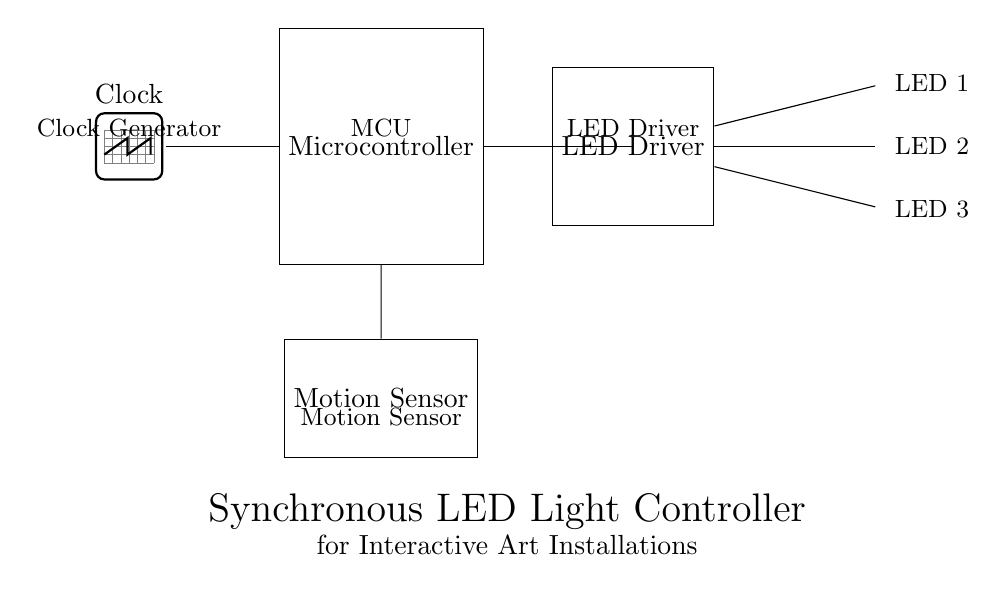what type of sensor is used in this circuit? The circuit diagram indicates a motion sensor, which is depicted in a rectangular shape labeled as "Motion Sensor". This is visible in the lower part of the diagram.
Answer: Motion Sensor how many LEDs are controlled in this circuit? The circuit shows three LED components labeled as LED 1, LED 2, and LED 3, indicating that three LEDs are controlled. They are connected to the LED driver in the diagram.
Answer: Three what connects the motion sensor to the microcontroller? The circuit diagram shows a direct line labeled from the motion sensor to the microcontroller, indicating a connection allowing the sensor to communicate its input (motion detection) to the microcontroller.
Answer: A direct line which component acts as the clock generator? The circuit identifies a component labeled as "Clock" at the top, which is an oscillator shape, indicating that it is the clock generator providing timing signals to the microcontroller.
Answer: Clock what is the function of the MCU in this configuration? The microcontroller, indicated by its label in the diagram, processes signals from the motion sensor and controls the LED driver based on the input, making it the central control unit in this circuit.
Answer: Control unit if the motion sensor detects motion, what will be activated? The motion sensor is connected to the microcontroller that triggers the LED driver, which in turn will activate the three LEDs when motion is detected. The connection indicates this flow of activation up to the LEDs.
Answer: LEDs how does the LED driver relate to the microcontroller? The diagram shows a connection line going from the microcontroller to the LED driver, indicating that the microcontroller sends control signals to the LED driver, which manages the power to the LEDs.
Answer: Control signal 